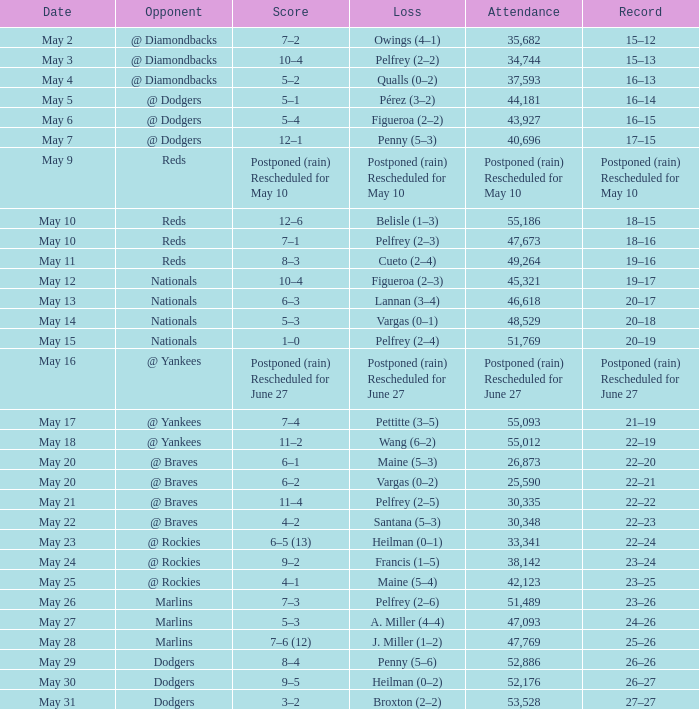Attendance of 30,335 had what record? 22–22. 